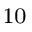Convert formula to latex. <formula><loc_0><loc_0><loc_500><loc_500>_ { 1 0 }</formula> 